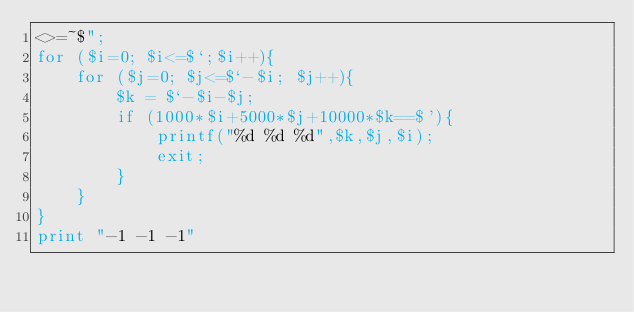<code> <loc_0><loc_0><loc_500><loc_500><_Perl_><>=~$";
for ($i=0; $i<=$`;$i++){
    for ($j=0; $j<=$`-$i; $j++){
        $k = $`-$i-$j;
        if (1000*$i+5000*$j+10000*$k==$'){
            printf("%d %d %d",$k,$j,$i);
            exit;
        }
    }
}
print "-1 -1 -1"</code> 